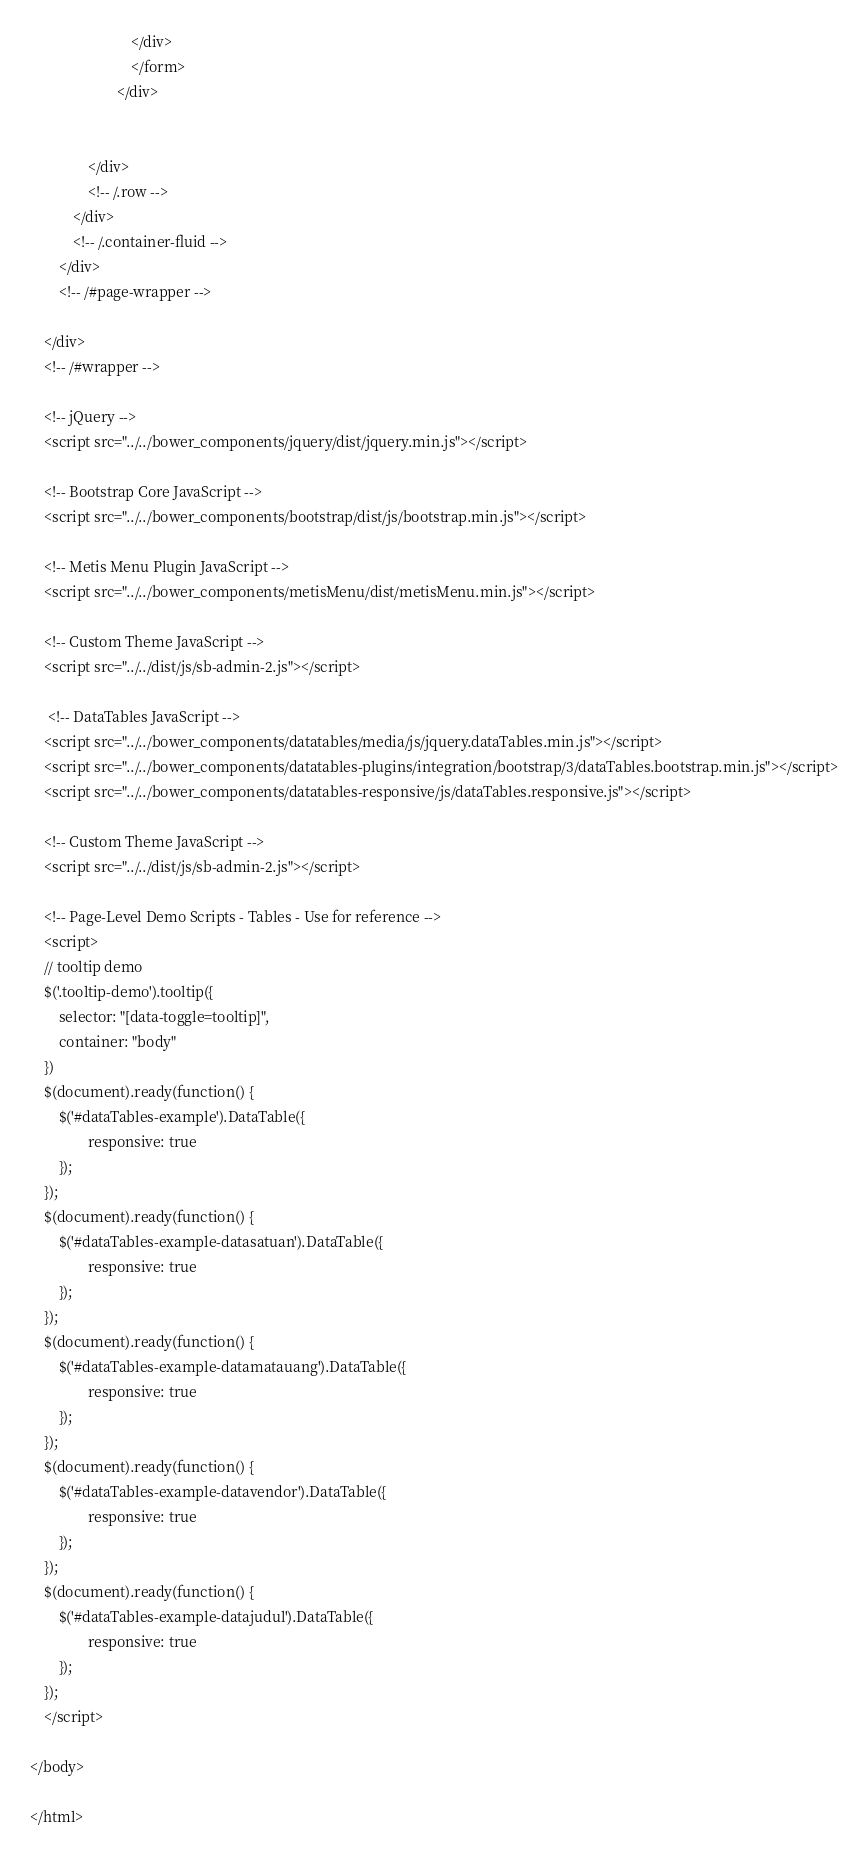Convert code to text. <code><loc_0><loc_0><loc_500><loc_500><_PHP_>                            </div>
                            </form>
                        </div>
                   
                
                </div>
                <!-- /.row -->
            </div>
            <!-- /.container-fluid -->
        </div>
        <!-- /#page-wrapper -->

    </div>
    <!-- /#wrapper -->

    <!-- jQuery -->
    <script src="../../bower_components/jquery/dist/jquery.min.js"></script>

    <!-- Bootstrap Core JavaScript -->
    <script src="../../bower_components/bootstrap/dist/js/bootstrap.min.js"></script>

    <!-- Metis Menu Plugin JavaScript -->
    <script src="../../bower_components/metisMenu/dist/metisMenu.min.js"></script>

    <!-- Custom Theme JavaScript -->
    <script src="../../dist/js/sb-admin-2.js"></script>
    
     <!-- DataTables JavaScript -->
    <script src="../../bower_components/datatables/media/js/jquery.dataTables.min.js"></script>
    <script src="../../bower_components/datatables-plugins/integration/bootstrap/3/dataTables.bootstrap.min.js"></script>
    <script src="../../bower_components/datatables-responsive/js/dataTables.responsive.js"></script>
    
    <!-- Custom Theme JavaScript -->
    <script src="../../dist/js/sb-admin-2.js"></script>

    <!-- Page-Level Demo Scripts - Tables - Use for reference -->
    <script>
	// tooltip demo
    $('.tooltip-demo').tooltip({
        selector: "[data-toggle=tooltip]",
        container: "body"
    })
    $(document).ready(function() {
        $('#dataTables-example').DataTable({
                responsive: true
        });
    });
	$(document).ready(function() {
        $('#dataTables-example-datasatuan').DataTable({
                responsive: true
        });
    });
	$(document).ready(function() {
        $('#dataTables-example-datamatauang').DataTable({
                responsive: true
        });
    });
	$(document).ready(function() {
        $('#dataTables-example-datavendor').DataTable({
                responsive: true
        });
    });
	$(document).ready(function() {
        $('#dataTables-example-datajudul').DataTable({
                responsive: true
        });
    });
    </script>

</body>

</html>
</code> 